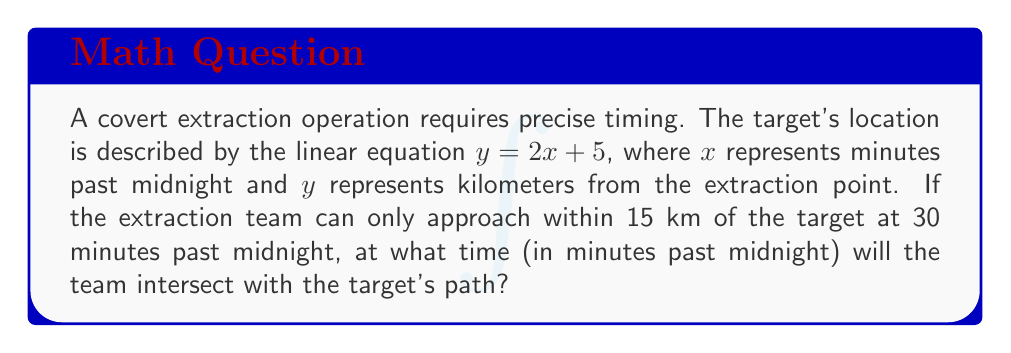Can you answer this question? Let's approach this step-by-step:

1) The target's location is given by the equation $y = 2x + 5$

2) We know that at 30 minutes past midnight, the extraction team is 15 km away from the target's path. Let's call the intersection point $(a, b)$

3) At 30 minutes past midnight, the target's location is:
   $y = 2(30) + 5 = 65$ km from the extraction point

4) The distance between the team's location and the target's location at this time is 15 km. We can represent this using the distance formula:
   $\sqrt{(a-30)^2 + (b-65)^2} = 15$

5) We also know that the intersection point $(a, b)$ must satisfy the target's path equation:
   $b = 2a + 5$

6) Substituting this into our distance equation:
   $\sqrt{(a-30)^2 + ((2a+5)-65)^2} = 15$

7) Simplifying:
   $\sqrt{(a-30)^2 + (2a-60)^2} = 15$

8) Squaring both sides:
   $(a-30)^2 + (2a-60)^2 = 225$

9) Expanding:
   $a^2 - 60a + 900 + 4a^2 - 240a + 3600 = 225$

10) Simplifying:
    $5a^2 - 300a + 4275 = 0$

11) This is a quadratic equation. We can solve it using the quadratic formula:
    $a = \frac{-b \pm \sqrt{b^2 - 4ac}}{2a}$

12) Plugging in our values:
    $a = \frac{300 \pm \sqrt{90000 - 85500}}{10} = \frac{300 \pm \sqrt{4500}}{10} = \frac{300 \pm 67.08}{10}$

13) This gives us two solutions: $a = 36.71$ or $a = 23.29$

14) Since time can't go backwards, we choose the later time: 36.71 minutes past midnight
Answer: 36.71 minutes past midnight 